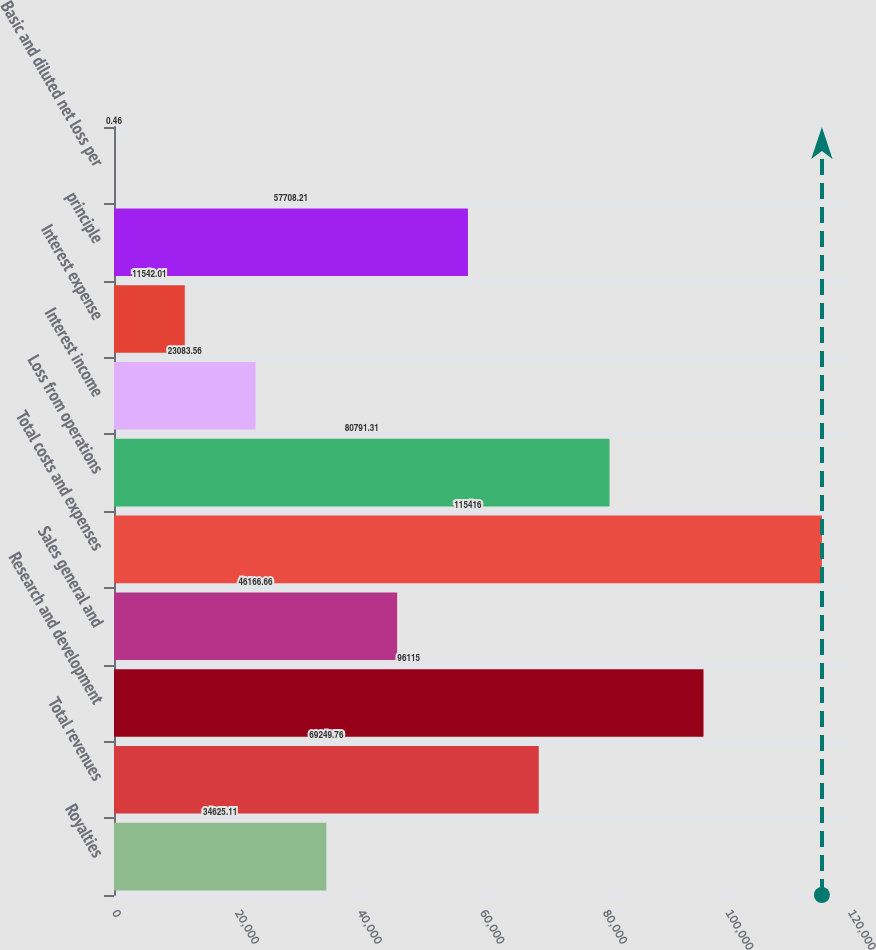Convert chart to OTSL. <chart><loc_0><loc_0><loc_500><loc_500><bar_chart><fcel>Royalties<fcel>Total revenues<fcel>Research and development<fcel>Sales general and<fcel>Total costs and expenses<fcel>Loss from operations<fcel>Interest income<fcel>Interest expense<fcel>principle<fcel>Basic and diluted net loss per<nl><fcel>34625.1<fcel>69249.8<fcel>96115<fcel>46166.7<fcel>115416<fcel>80791.3<fcel>23083.6<fcel>11542<fcel>57708.2<fcel>0.46<nl></chart> 